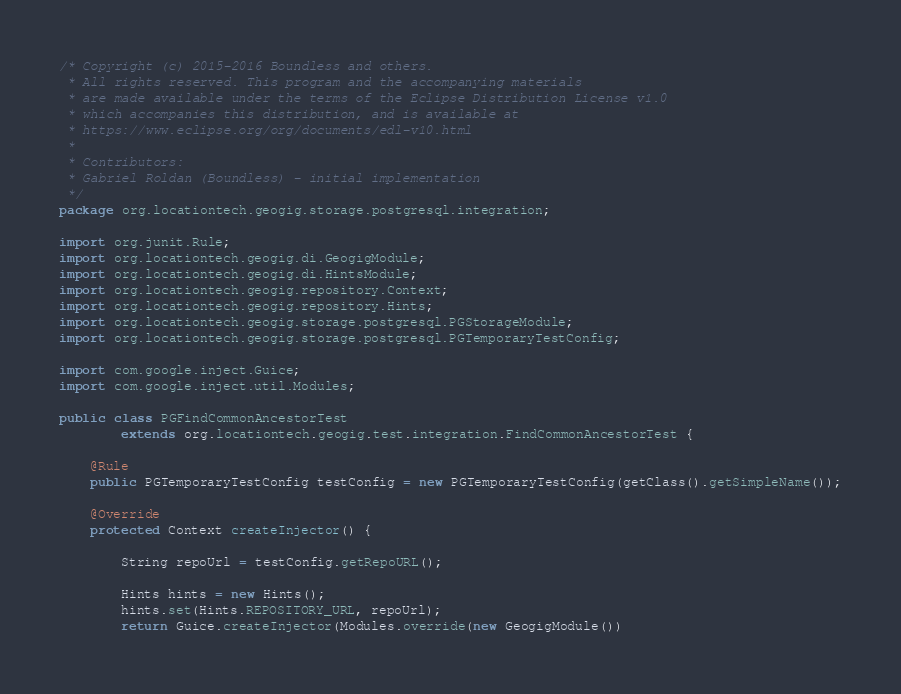<code> <loc_0><loc_0><loc_500><loc_500><_Java_>/* Copyright (c) 2015-2016 Boundless and others.
 * All rights reserved. This program and the accompanying materials
 * are made available under the terms of the Eclipse Distribution License v1.0
 * which accompanies this distribution, and is available at
 * https://www.eclipse.org/org/documents/edl-v10.html
 *
 * Contributors:
 * Gabriel Roldan (Boundless) - initial implementation
 */
package org.locationtech.geogig.storage.postgresql.integration;

import org.junit.Rule;
import org.locationtech.geogig.di.GeogigModule;
import org.locationtech.geogig.di.HintsModule;
import org.locationtech.geogig.repository.Context;
import org.locationtech.geogig.repository.Hints;
import org.locationtech.geogig.storage.postgresql.PGStorageModule;
import org.locationtech.geogig.storage.postgresql.PGTemporaryTestConfig;

import com.google.inject.Guice;
import com.google.inject.util.Modules;

public class PGFindCommonAncestorTest
        extends org.locationtech.geogig.test.integration.FindCommonAncestorTest {

    @Rule
    public PGTemporaryTestConfig testConfig = new PGTemporaryTestConfig(getClass().getSimpleName());

    @Override
    protected Context createInjector() {

        String repoUrl = testConfig.getRepoURL();

        Hints hints = new Hints();
        hints.set(Hints.REPOSITORY_URL, repoUrl);
        return Guice.createInjector(Modules.override(new GeogigModule())</code> 